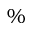Convert formula to latex. <formula><loc_0><loc_0><loc_500><loc_500>\%</formula> 